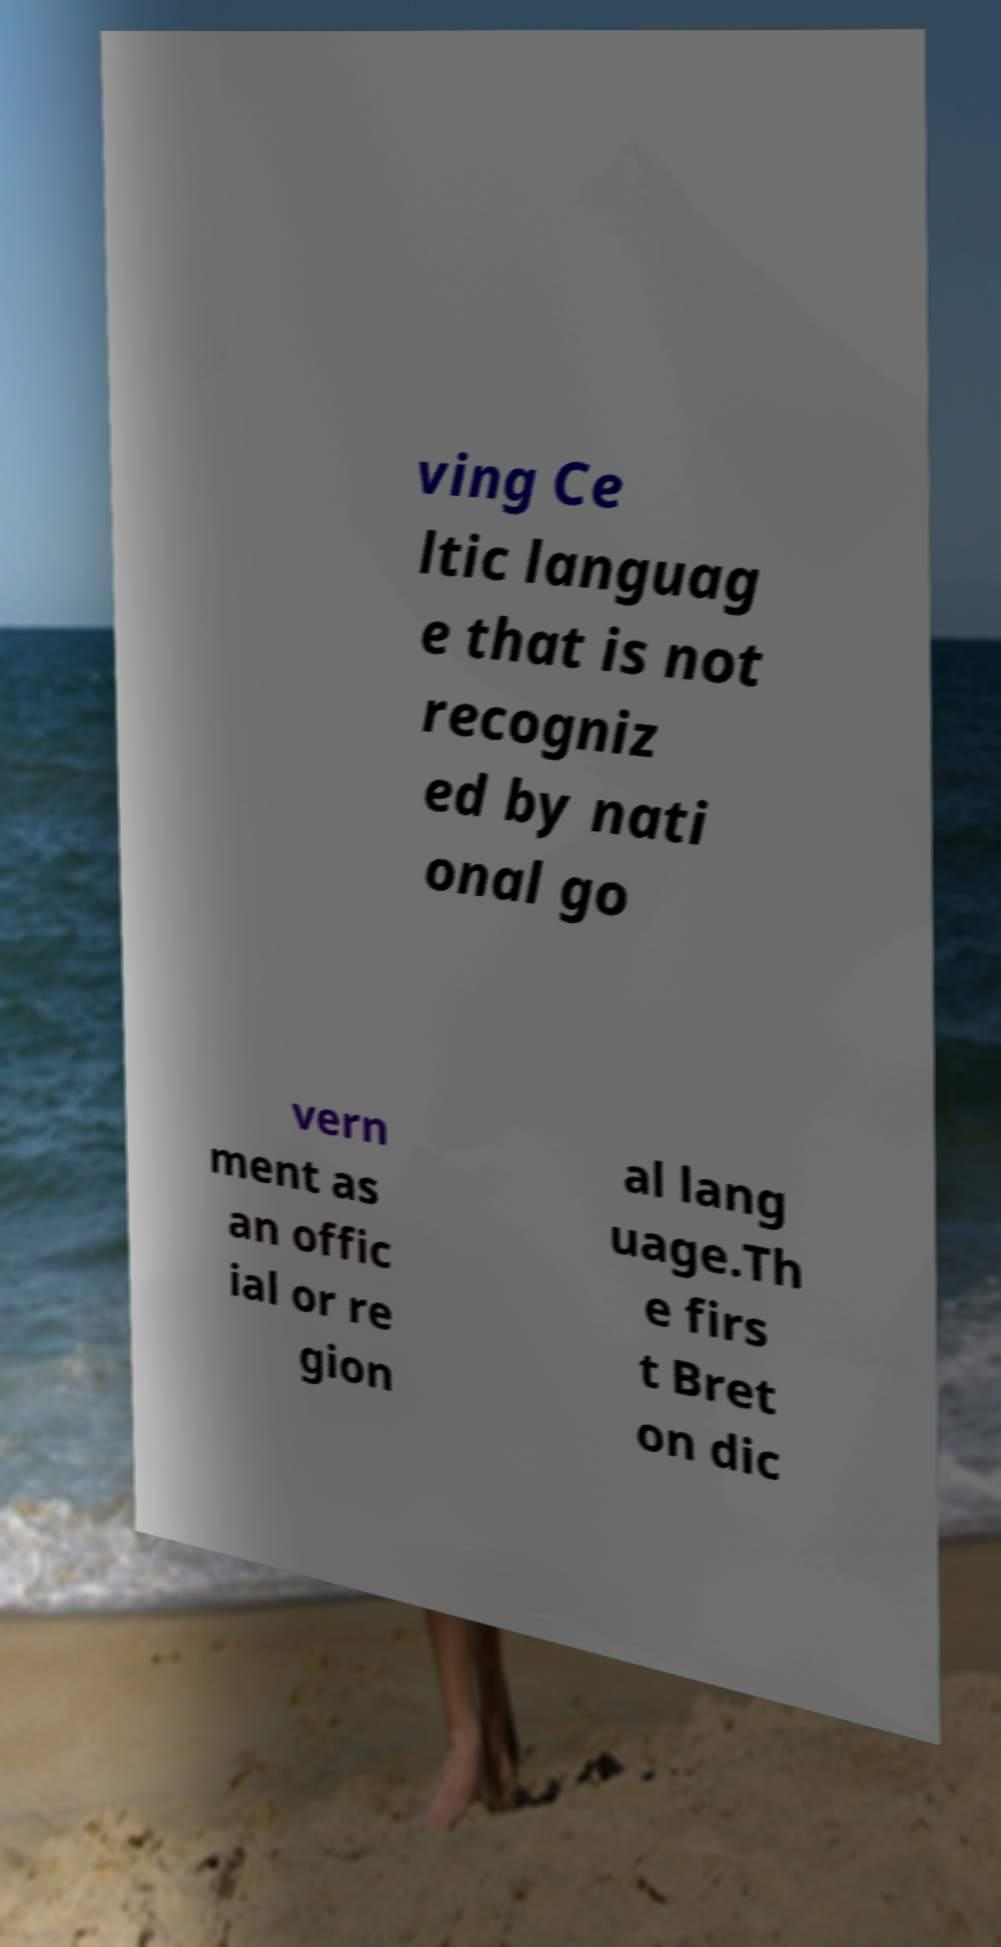There's text embedded in this image that I need extracted. Can you transcribe it verbatim? ving Ce ltic languag e that is not recogniz ed by nati onal go vern ment as an offic ial or re gion al lang uage.Th e firs t Bret on dic 